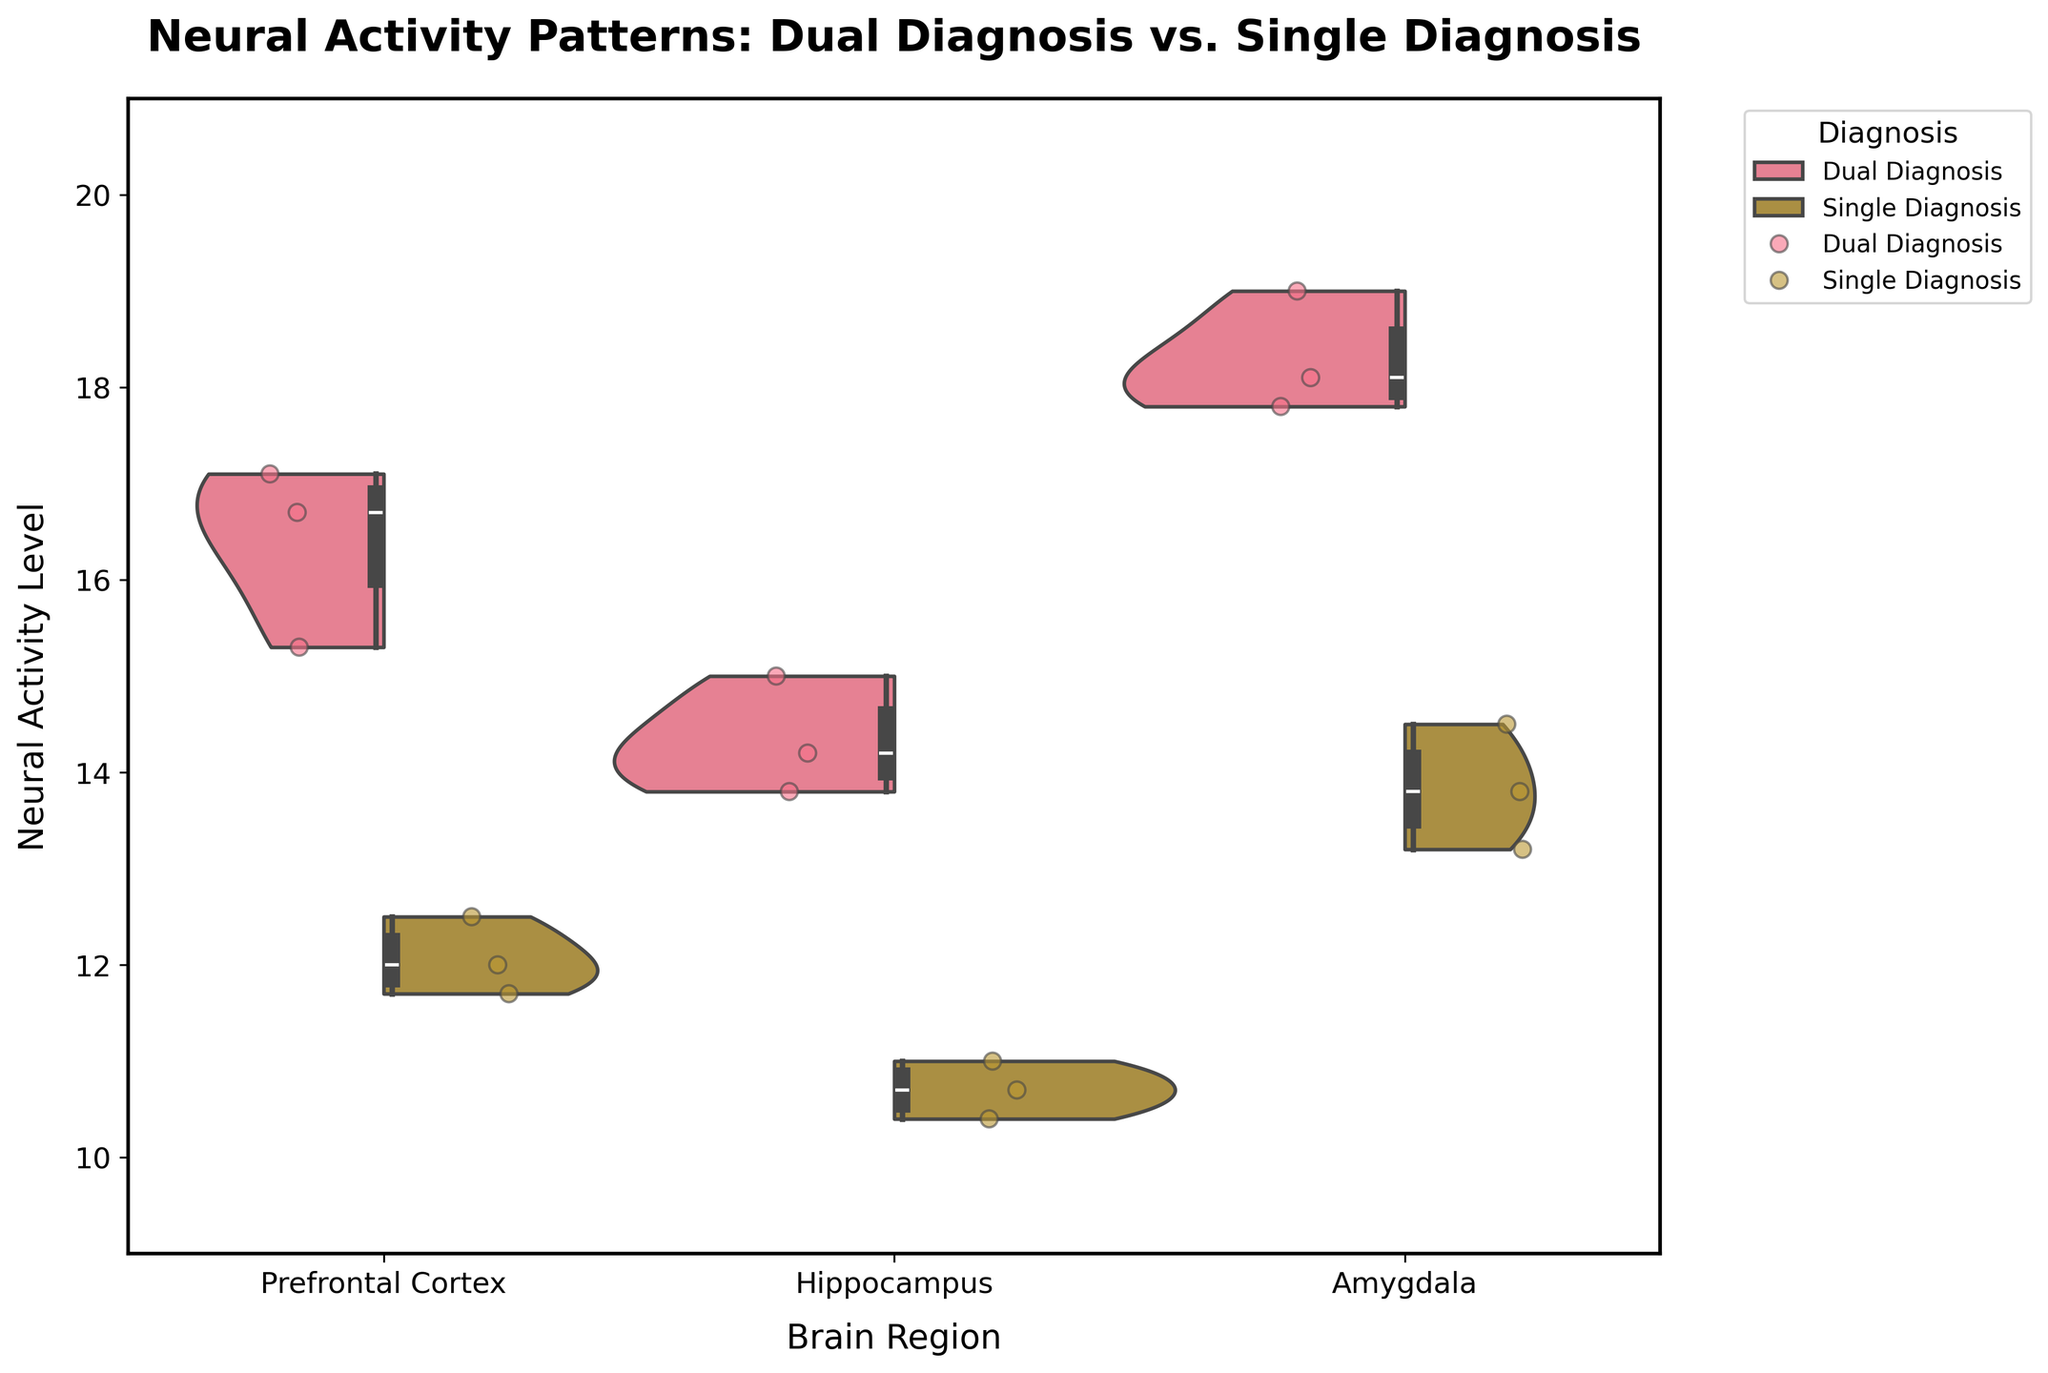How many brain regions are compared in this figure? The x-axis labels indicate the different brain regions being compared. There are three distinct regions mentioned: Prefrontal Cortex, Hippocampus, and Amygdala.
Answer: Three Which diagnosis group shows higher neural activity levels in the Prefrontal Cortex? By examining the height and width of the violin plots for the Prefrontal Cortex, it can be seen that the Dual Diagnosis group shows higher activity levels. The wider distribution and higher median line of the box plot within the violin plot for Dual Diagnosis indicate this.
Answer: Dual Diagnosis What is the range of neural activity levels observed in the Amygdala for the Single Diagnosis group? The Single Diagnosis group’s neural activity levels in the Amygdala can be inferred from the violin plot and the box plot overlaid on it. The plot shows the minimum and maximum activity levels as the range indicated by the lower and upper ends of the violin plot.
Answer: 13.2 to 14.5 Does the Dual Diagnosis group show greater activity levels in the Hippocampus compared to the Single Diagnosis group? To determine this, compare the height and position of the box plots within the violin plots of the Hippocampus for both diagnosis groups. The Dual Diagnosis group has higher median and overall activity levels compared to the Single Diagnosis group.
Answer: Yes What is the median neural activity level for the Dual Diagnosis group in the Amygdala? The median is represented by the line inside the box plot within the violin plot. For the Amygdala, the line within the Dual Diagnosis group box plot shows the median activity level.
Answer: Around 18.1 Which brain region shows the smallest overall variation in neural activity levels for the Dual Diagnosis group? To find the region with the smallest variation, observe the thickness of the violin plots and the length of the box plots. The thinner the violin plot and the shorter the box plot, the smaller the variation. In this case, the Prefrontal Cortex violin plot shows the smallest variation.
Answer: Prefrontal Cortex Are there any overlapping activity levels between the Dual and Single Diagnosis groups in the Hippocampus? By observing the violin plots for the Hippocampus, overlap areas where the activity levels of both groups coincide can be identified. Both plots show slight common overlapping areas, indicating shared activity levels.
Answer: Yes Which brain region has the highest maximum neural activity recorded for the Dual Diagnosis group? The maximum neural activity level is observed by looking at the uppermost point of the violin plots. For the Dual Diagnosis group, the highest maximum activity level is recorded in the Amygdala.
Answer: Amygdala 